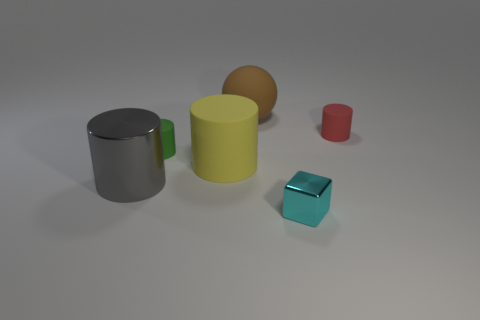Is the number of big gray cylinders less than the number of small rubber cylinders?
Your answer should be very brief. Yes. What number of things have the same color as the rubber ball?
Provide a short and direct response. 0. Are there more matte objects than small cyan cubes?
Your answer should be compact. Yes. There is a red rubber object that is the same shape as the tiny green matte thing; what is its size?
Your response must be concise. Small. Is the big ball made of the same material as the small cylinder to the right of the tiny cube?
Give a very brief answer. Yes. What number of things are either big green cylinders or brown objects?
Offer a very short reply. 1. Do the cylinder right of the brown matte thing and the gray shiny object that is in front of the green object have the same size?
Your answer should be compact. No. How many cubes are big red objects or large metallic things?
Provide a short and direct response. 0. Are any large yellow metal cylinders visible?
Offer a very short reply. No. Are there any other things that are the same shape as the brown rubber object?
Your response must be concise. No. 